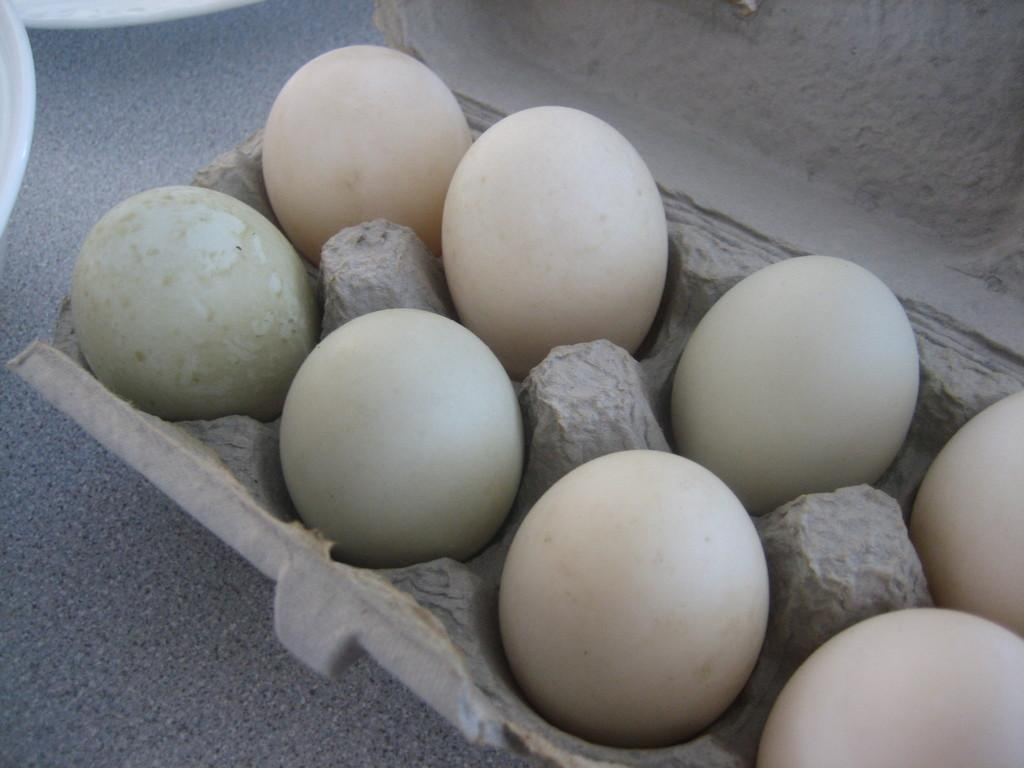What is present in the image that is typically used for cooking or baking? There are eggs in the image, which are commonly used for cooking or baking. How are the eggs arranged in the image? The eggs are placed in a tray in the image. What else can be seen on the left side of the image? There are bowls on the left top of the image. What type of vein can be seen running through the eggs in the image? There are no veins present in the eggs or the image; the image only shows eggs placed in a tray. 